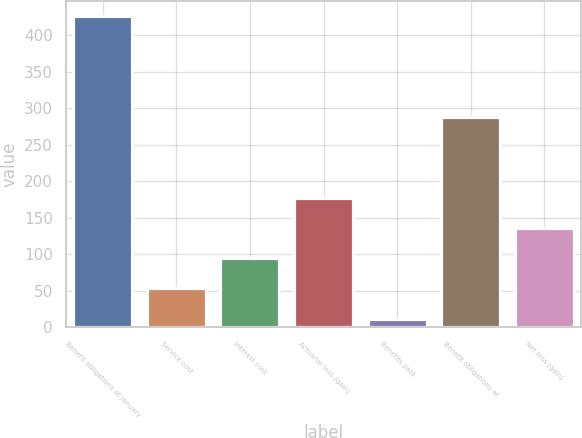Convert chart. <chart><loc_0><loc_0><loc_500><loc_500><bar_chart><fcel>Benefit obligations at January<fcel>Service cost<fcel>Interest cost<fcel>Actuarial loss (gain)<fcel>Benefits paid<fcel>Benefit obligations at<fcel>Net loss (gain)<nl><fcel>426<fcel>53.4<fcel>94.8<fcel>177.6<fcel>12<fcel>288<fcel>136.2<nl></chart> 